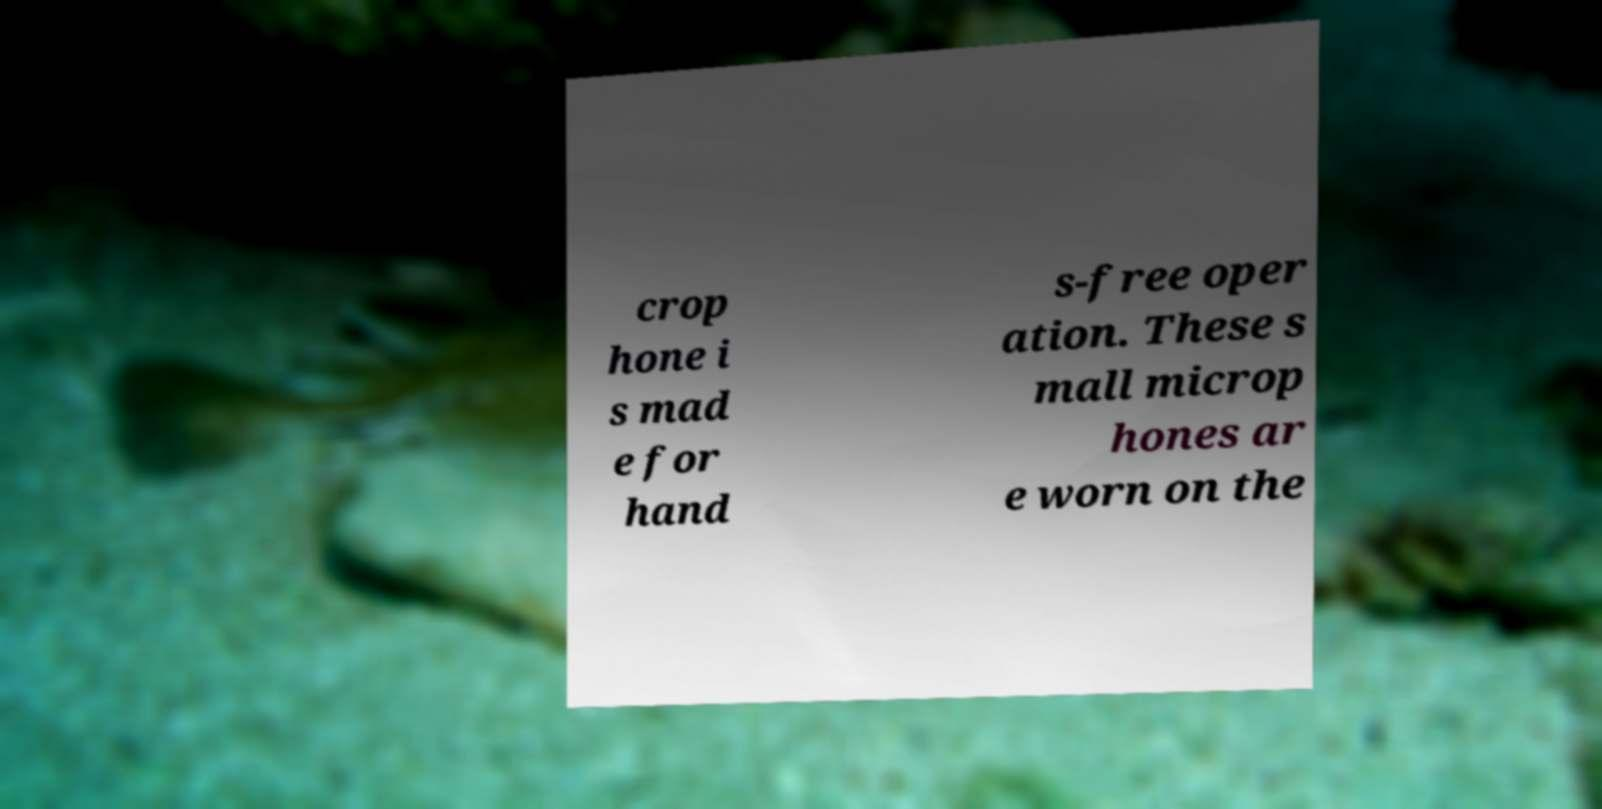Please read and relay the text visible in this image. What does it say? crop hone i s mad e for hand s-free oper ation. These s mall microp hones ar e worn on the 